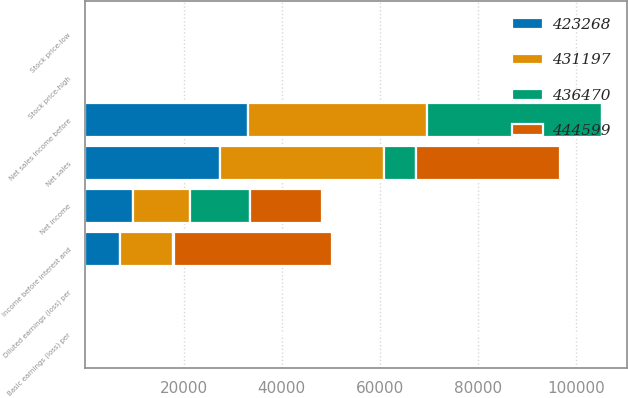Convert chart to OTSL. <chart><loc_0><loc_0><loc_500><loc_500><stacked_bar_chart><ecel><fcel>Net sales<fcel>Income before interest and<fcel>Basic earnings (loss) per<fcel>Diluted earnings (loss) per<fcel>Stock price-high<fcel>Stock price-low<fcel>Net sales Income before<fcel>Net income<nl><fcel>423268<fcel>27482<fcel>7127<fcel>0.07<fcel>0.07<fcel>19.23<fcel>16.28<fcel>33170<fcel>9626<nl><fcel>431197<fcel>33315<fcel>10674<fcel>0.1<fcel>0.1<fcel>19.2<fcel>17.23<fcel>36560<fcel>11595<nl><fcel>444599<fcel>29527<fcel>32336<fcel>0.31<fcel>0.31<fcel>20.8<fcel>17.84<fcel>22.11<fcel>14598<nl><fcel>436470<fcel>6532<fcel>177<fcel>0<fcel>0<fcel>22.11<fcel>18.85<fcel>35515<fcel>12360<nl></chart> 